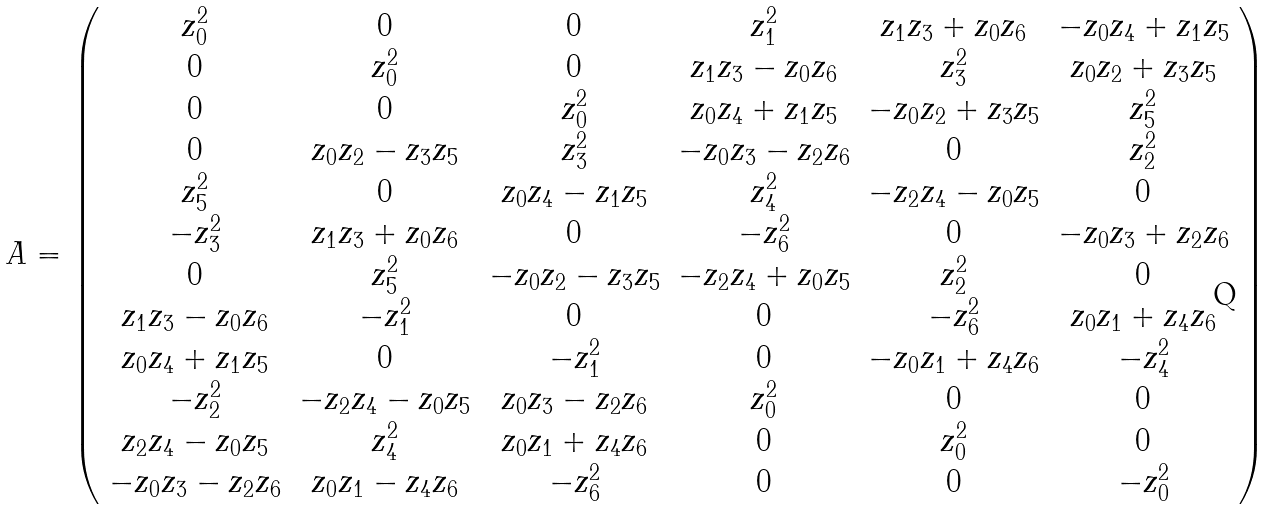Convert formula to latex. <formula><loc_0><loc_0><loc_500><loc_500>A = { \left ( \begin{array} { c c c c c c } z _ { 0 } ^ { 2 } & 0 & 0 & z _ { 1 } ^ { 2 } & z _ { 1 } z _ { 3 } + z _ { 0 } z _ { 6 } & - z _ { 0 } z _ { 4 } + z _ { 1 } z _ { 5 } \\ 0 & z _ { 0 } ^ { 2 } & 0 & z _ { 1 } z _ { 3 } - z _ { 0 } z _ { 6 } & z _ { 3 } ^ { 2 } & z _ { 0 } z _ { 2 } + z _ { 3 } z _ { 5 } \\ 0 & 0 & z _ { 0 } ^ { 2 } & z _ { 0 } z _ { 4 } + z _ { 1 } z _ { 5 } & - z _ { 0 } z _ { 2 } + z _ { 3 } z _ { 5 } & z _ { 5 } ^ { 2 } \\ 0 & z _ { 0 } z _ { 2 } - z _ { 3 } z _ { 5 } & z _ { 3 } ^ { 2 } & - z _ { 0 } z _ { 3 } - z _ { 2 } z _ { 6 } & 0 & z _ { 2 } ^ { 2 } \\ z _ { 5 } ^ { 2 } & 0 & z _ { 0 } z _ { 4 } - z _ { 1 } z _ { 5 } & z _ { 4 } ^ { 2 } & - z _ { 2 } z _ { 4 } - z _ { 0 } z _ { 5 } & 0 \\ - z _ { 3 } ^ { 2 } & z _ { 1 } z _ { 3 } + z _ { 0 } z _ { 6 } & 0 & - z _ { 6 } ^ { 2 } & 0 & - z _ { 0 } z _ { 3 } + z _ { 2 } z _ { 6 } \\ 0 & z _ { 5 } ^ { 2 } & - z _ { 0 } z _ { 2 } - z _ { 3 } z _ { 5 } & - z _ { 2 } z _ { 4 } + z _ { 0 } z _ { 5 } & z _ { 2 } ^ { 2 } & 0 \\ z _ { 1 } z _ { 3 } - z _ { 0 } z _ { 6 } & - z _ { 1 } ^ { 2 } & 0 & 0 & - z _ { 6 } ^ { 2 } & z _ { 0 } z _ { 1 } + z _ { 4 } z _ { 6 } \\ z _ { 0 } z _ { 4 } + z _ { 1 } z _ { 5 } & 0 & - z _ { 1 } ^ { 2 } & 0 & - z _ { 0 } z _ { 1 } + z _ { 4 } z _ { 6 } & - z _ { 4 } ^ { 2 } \\ - z _ { 2 } ^ { 2 } & - z _ { 2 } z _ { 4 } - z _ { 0 } z _ { 5 } & z _ { 0 } z _ { 3 } - z _ { 2 } z _ { 6 } & z _ { 0 } ^ { 2 } & 0 & 0 \\ z _ { 2 } z _ { 4 } - z _ { 0 } z _ { 5 } & z _ { 4 } ^ { 2 } & z _ { 0 } z _ { 1 } + z _ { 4 } z _ { 6 } & 0 & z _ { 0 } ^ { 2 } & 0 \\ - z _ { 0 } z _ { 3 } - z _ { 2 } z _ { 6 } & z _ { 0 } z _ { 1 } - z _ { 4 } z _ { 6 } & - z _ { 6 } ^ { 2 } & 0 & 0 & - z _ { 0 } ^ { 2 } \end{array} \right ) }</formula> 